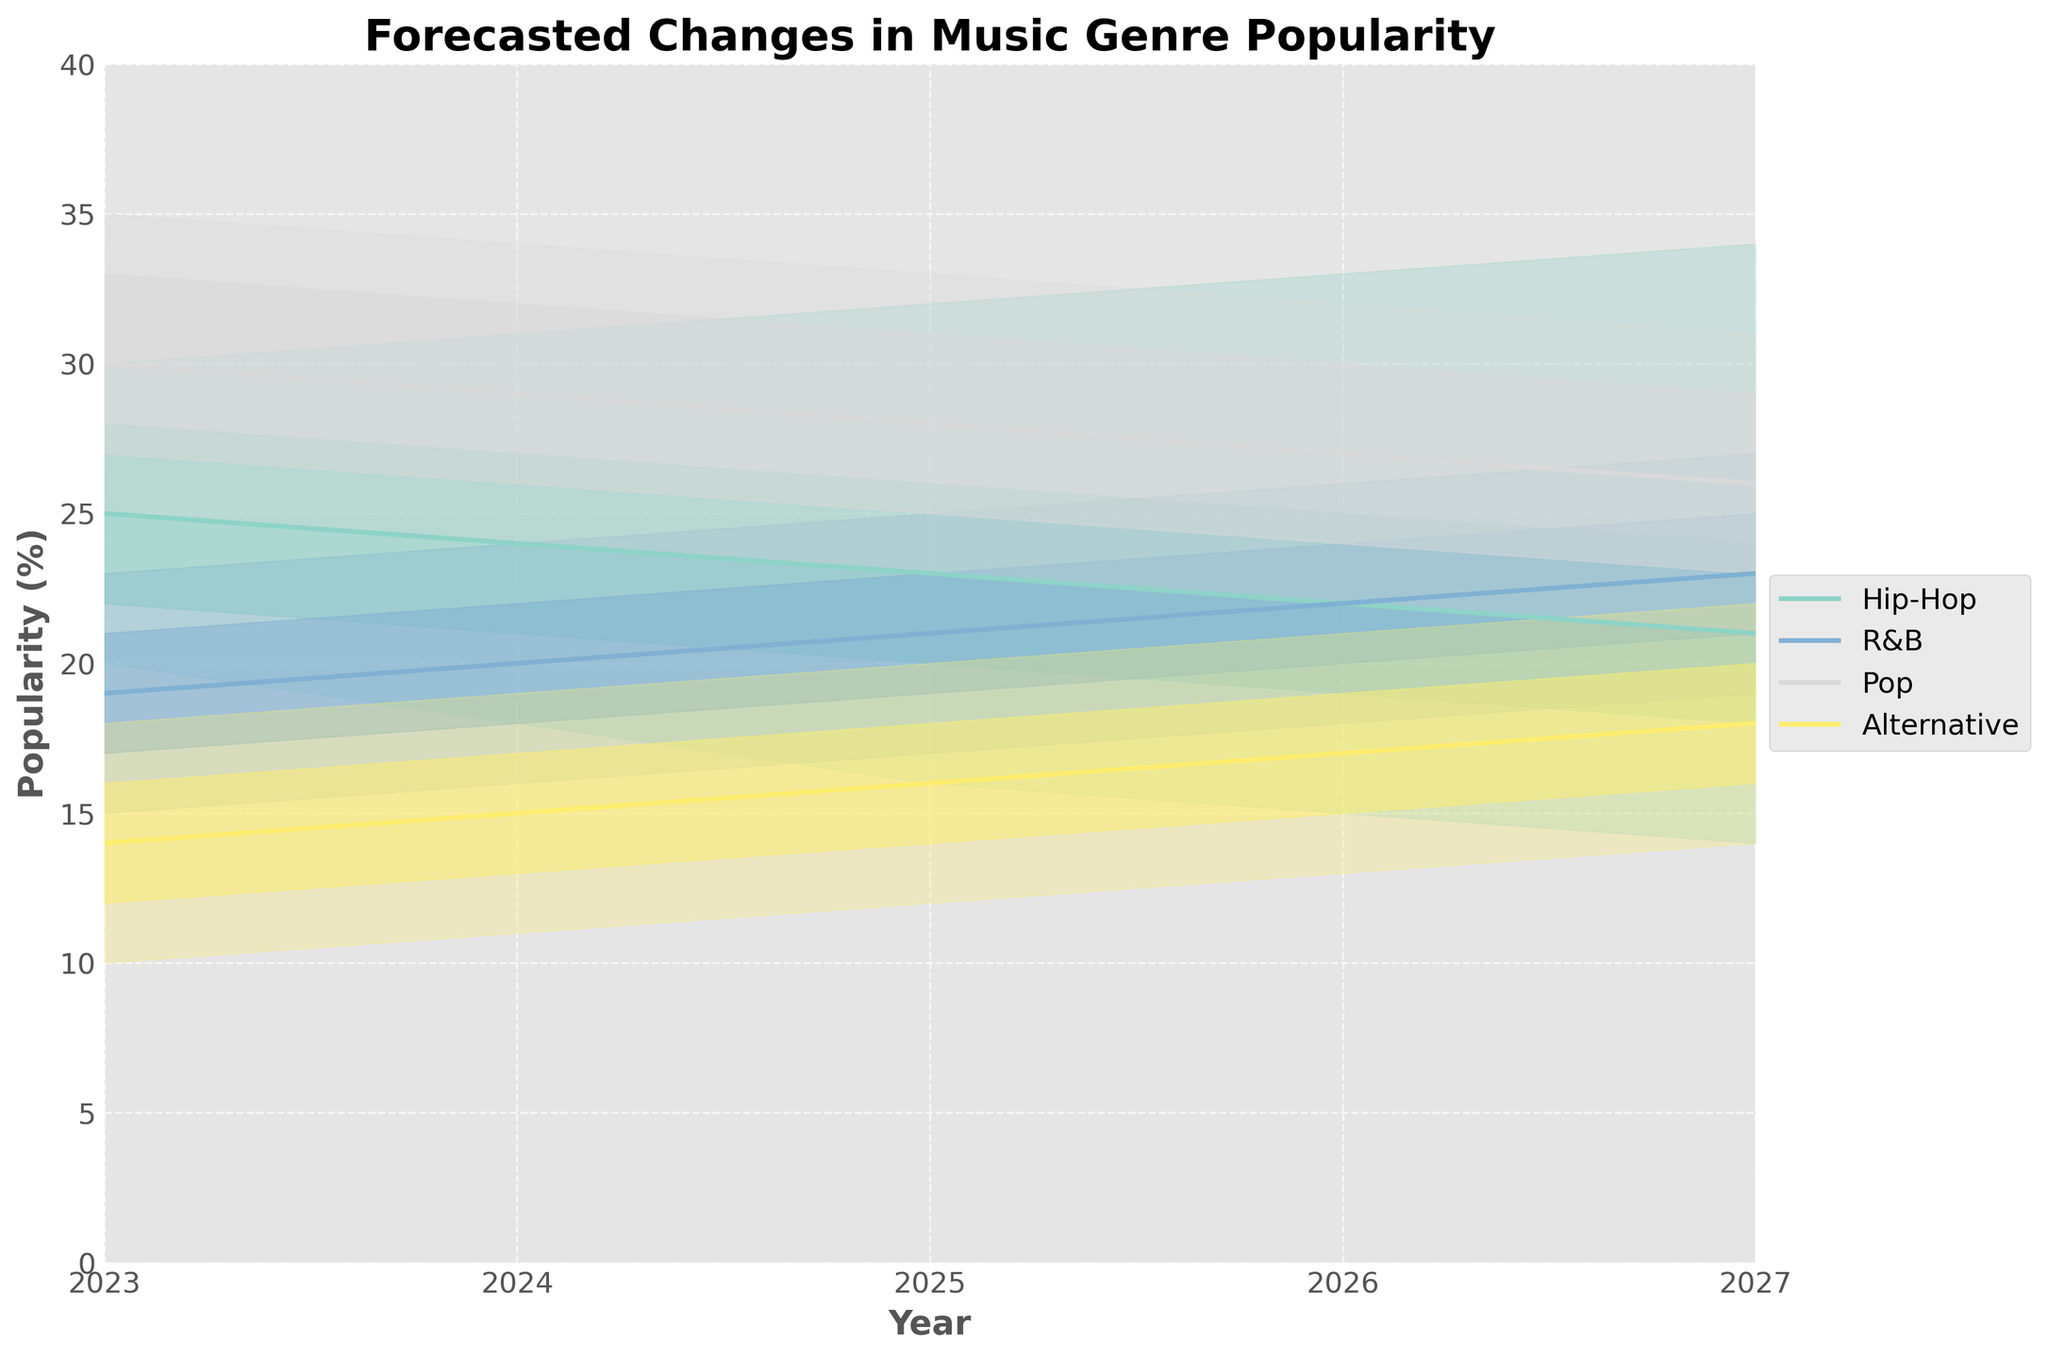What is the title of the chart? The title is bold and located at the top of the chart.
Answer: Forecasted Changes in Music Genre Popularity Which genre has the highest median popularity in 2025? Median popularity values are represented by the central line in each band. The Pop genre has the highest median value in 2025.
Answer: Pop In 2024, what is the range of forecasted popularity for Hip-Hop? The range is determined by the lowest and highest values in the shaded area for Hip-Hop in 2024. It spans from 18% to 31%.
Answer: 18% to 31% By how much does the median popularity of R&B increase from 2023 to 2027? Subtract the 2023 median value (19%) from the 2027 median value (23%).
Answer: 4% Which genre shows a steady increase in median popularity over the years? The R&B genre is the only one whose median values consistently rise each year from 2023 to 2027.
Answer: R&B Between 2023 and 2027, which genre is expected to see the largest decrease in high-end popularity? The high values for Pop drop from 35% in 2023 to 31% in 2027, which is a decrease of 4 percentage points.
Answer: Pop How does the uncertainty in the popularity forecast for Alternative music change from 2023 to 2027? The spread between low and high values shows increasing uncertainty from 2023 to 2027, broadening from 8% (10% to 18%) to 8% (14% to 22%).
Answer: Increases slightly In which year is the high-end forecast for Hip-Hop at its peak? The highest value in the shaded area for Hip-Hop is 34%, which is in 2027.
Answer: 2027 Compare the median popularity forecast for Hip-Hop and Alternative in 2024. Which one is higher? The median value for Hip-Hop in 2024 is 24%, while for Alternative it is 15%.
Answer: Hip-Hop What trend can be observed for the median popularity of Pop music from 2023 to 2027? The median popularity of Pop music shows a decreasing trend, starting at 30% in 2023 and falling to 26% in 2027.
Answer: Decreasing trend 